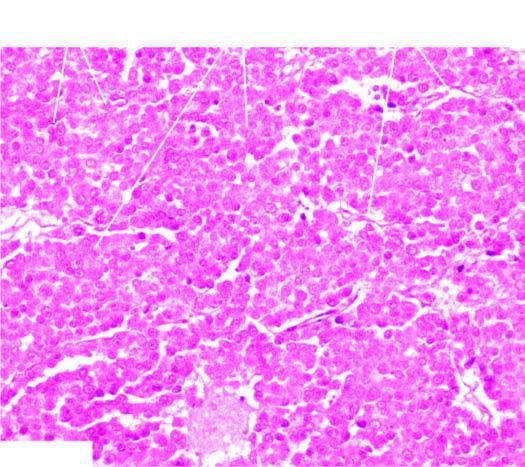what are masses of large uniform tumour cells separated by?
Answer the question using a single word or phrase. Scanty fibrous stroma that is infiltrated by lymphocytes 